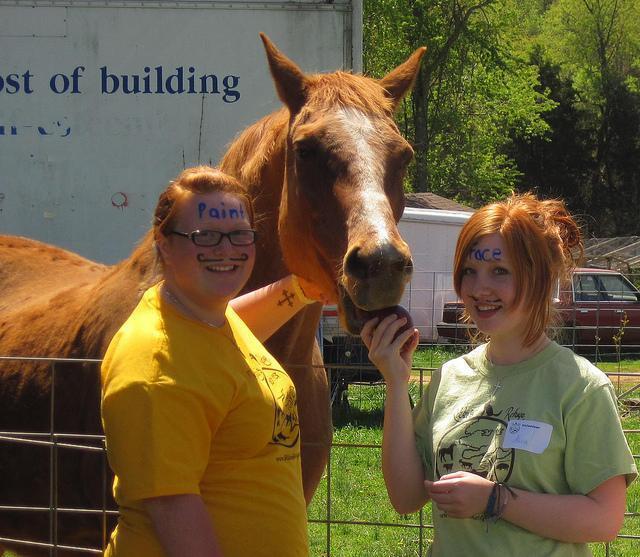How many people are in the photo?
Give a very brief answer. 2. How many trucks can be seen?
Give a very brief answer. 2. How many dogs are there with brown color?
Give a very brief answer. 0. 